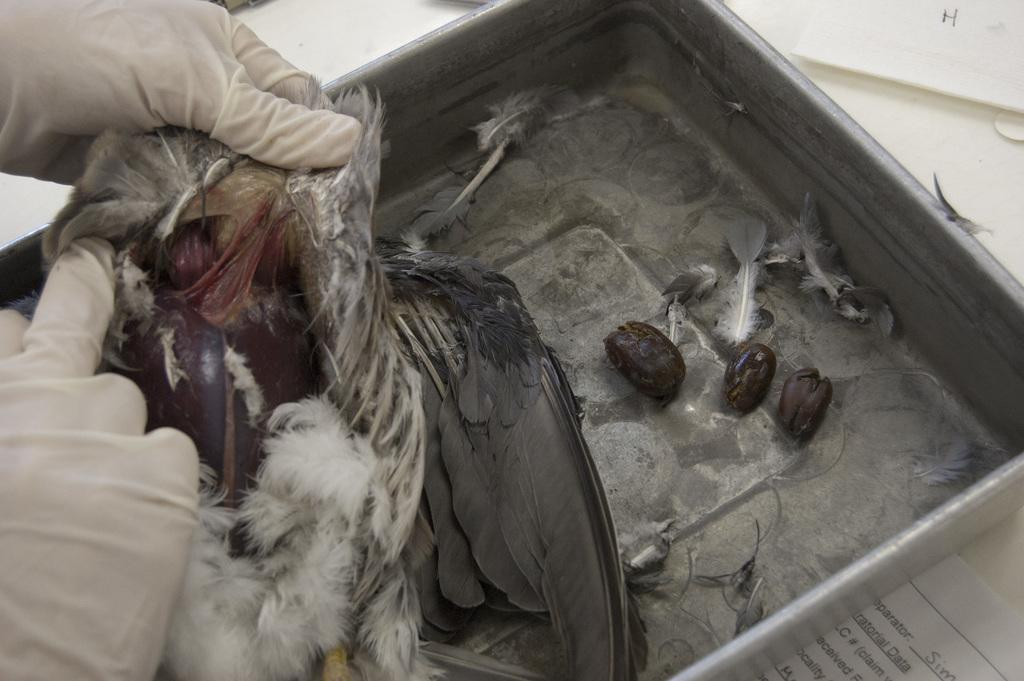What is being held in the image? There is a bird held with hands in the image. What else can be seen in the image besides the bird? There is paper and a tray with feathers in the image. What might be used to hold the feathers? The tray is used to hold the feathers. What is on the platform in the image? There are objects on a platform in the image. What type of calendar is hanging on the wall in the image? There is no calendar present in the image. What is being cooked in the stew in the image? There is no stew present in the image. 